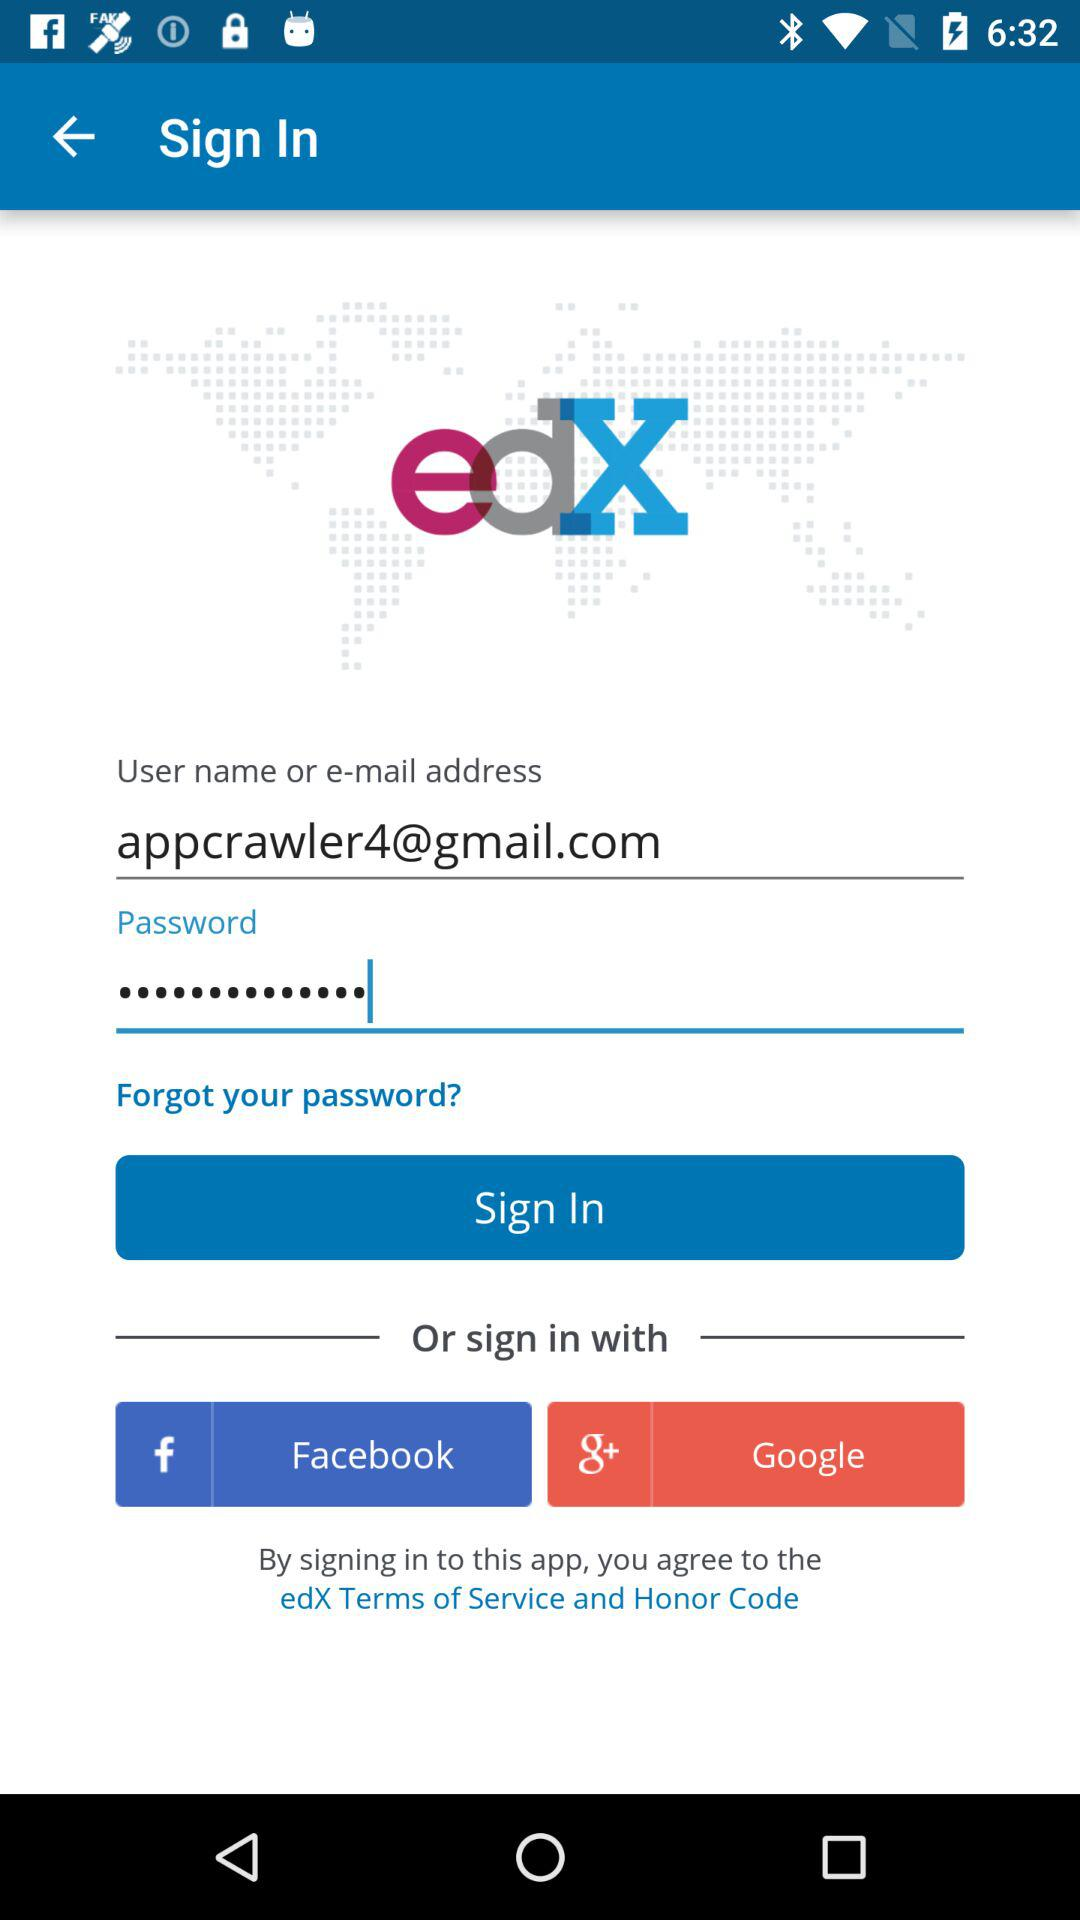How many fields are there for entering login credentials?
Answer the question using a single word or phrase. 2 